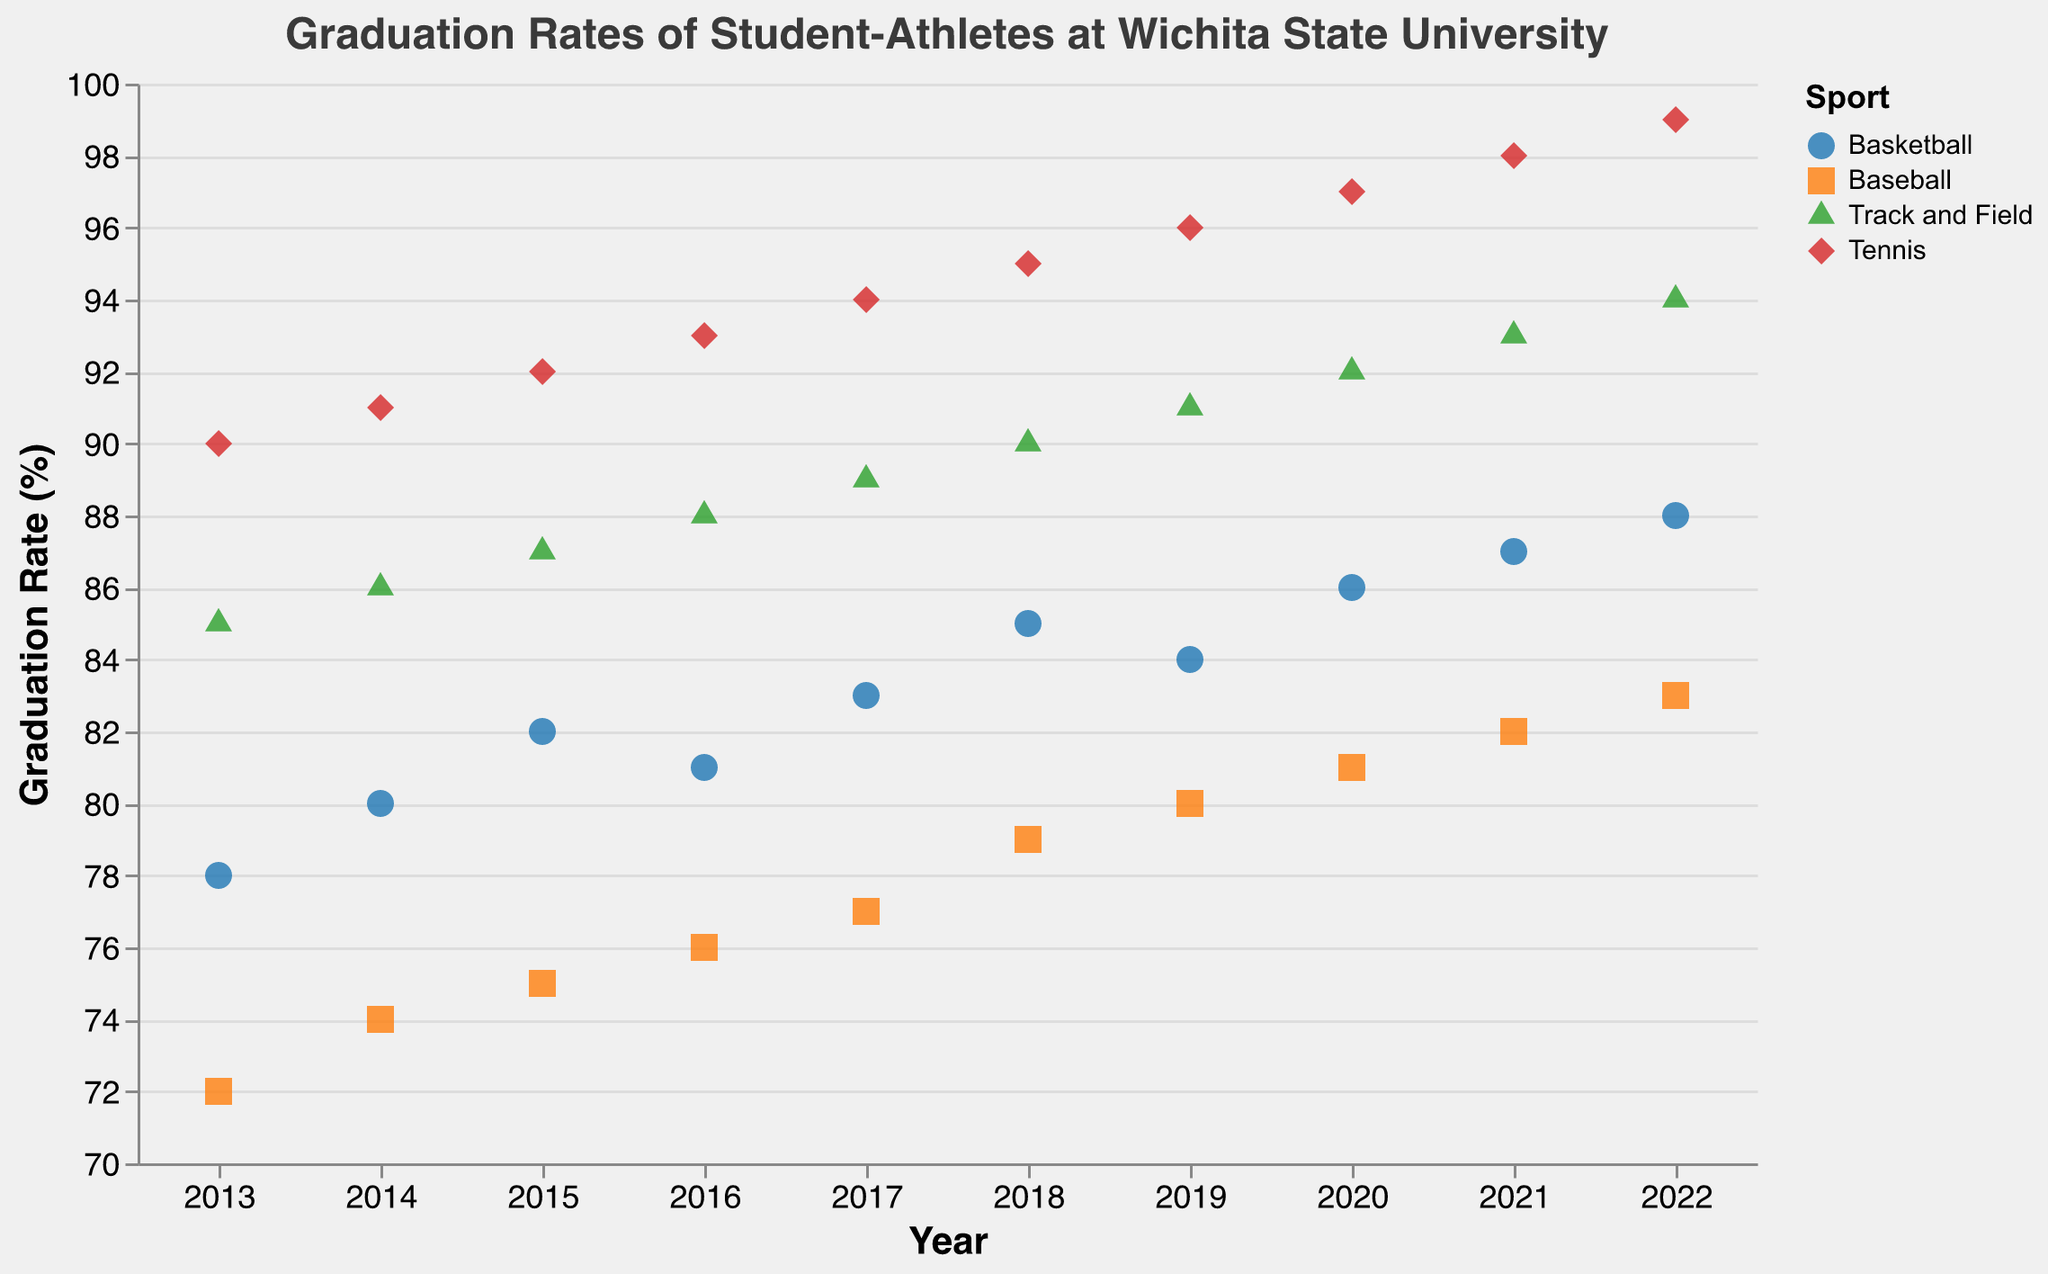What's the graduation rate for Tennis in 2020? Locate the Tennis points on the plot and find the one corresponding to the year 2020. The Graduation Rate value is marked next to the point.
Answer: 97 How did the graduation rate for Basketball change from 2013 to 2014? Find the points for Basketball in 2013 and 2014 and look at their Graduation Rate values. Subtract the 2013 value (78) from the 2014 value (80).
Answer: Increased by 2% Which sport had the highest graduation rate in 2022? Look at the points for 2022 across all sports and identify the highest Graduation Rate. Tennis has the highest value at 99.
Answer: Tennis What is the overall trend for the graduation rate in Baseball from 2013 to 2022? Observe the Baseball points over the years from 2013 to 2022 and describe the general direction. The graduation rate steadily increases from 72 to 83 over this period.
Answer: It's increasing Which sport had the lowest graduation rate in 2017, and what was the rate? Check all sports' graduation rates for 2017 and identify the lowest. The lowest value is for Baseball at 77.
Answer: Baseball, 77% What's the average graduation rate for Track and Field between 2018 and 2020? Identify the Graduation Rate values for Track and Field in 2018, 2019, and 2020 (90, 91, 92). Sum these values and divide by 3 to calculate the average. \( \frac{90 + 91 + 92}{3} = 91 \)
Answer: 91 Compare the graduation rate trends of Basketball and Tennis over the past decade. Describe how each sport's graduation rates have changed over the years. Basketball's rates increase from 78 to 88, while Tennis's rates increase from 90 to 99.
Answer: Both are increasing, but Tennis has a higher overall rate Which sport experienced the highest increase in graduation rates between 2013 and 2022? Calculate the difference in graduation rates between 2013 and 2022 for each sport. Tennis increased from 90 to 99, an increase of 9, which is the highest.
Answer: Tennis How many sports had a graduation rate above 80% in 2015? Look at the points for 2015 and count the number of sports with Graduation Rate values greater than 80. Track and Field and Tennis are above 80.
Answer: Two sports Is there any sport with a consistent graduation rate increase every year? Check each sport's graduation rates year by year to identify any sport with no decreases in rates. Tennis shows a consistent increase every year.
Answer: Tennis 